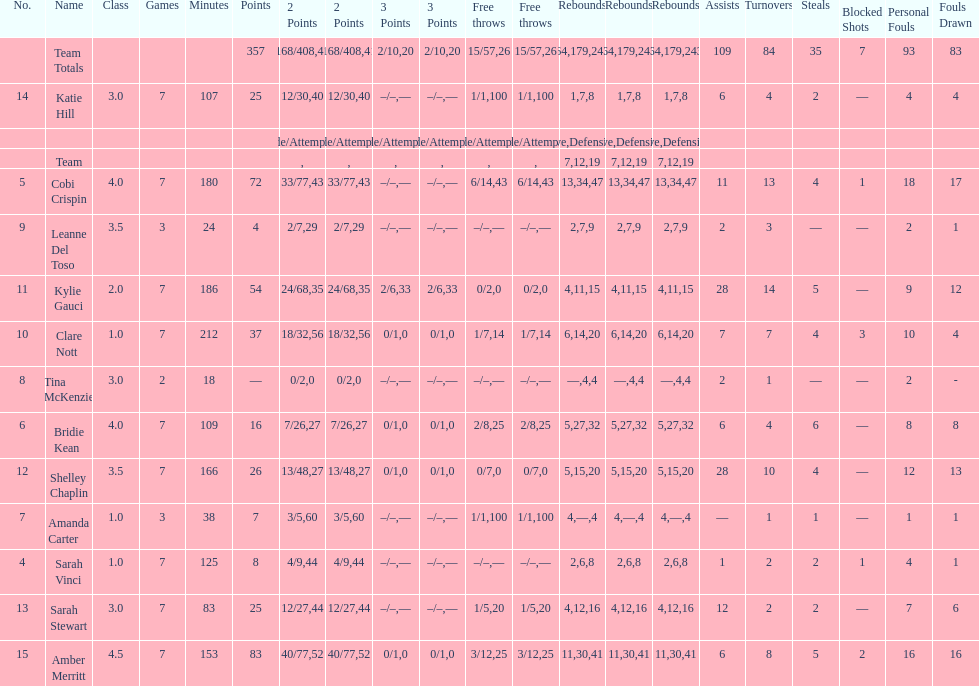Which player played in the least games? Tina McKenzie. 